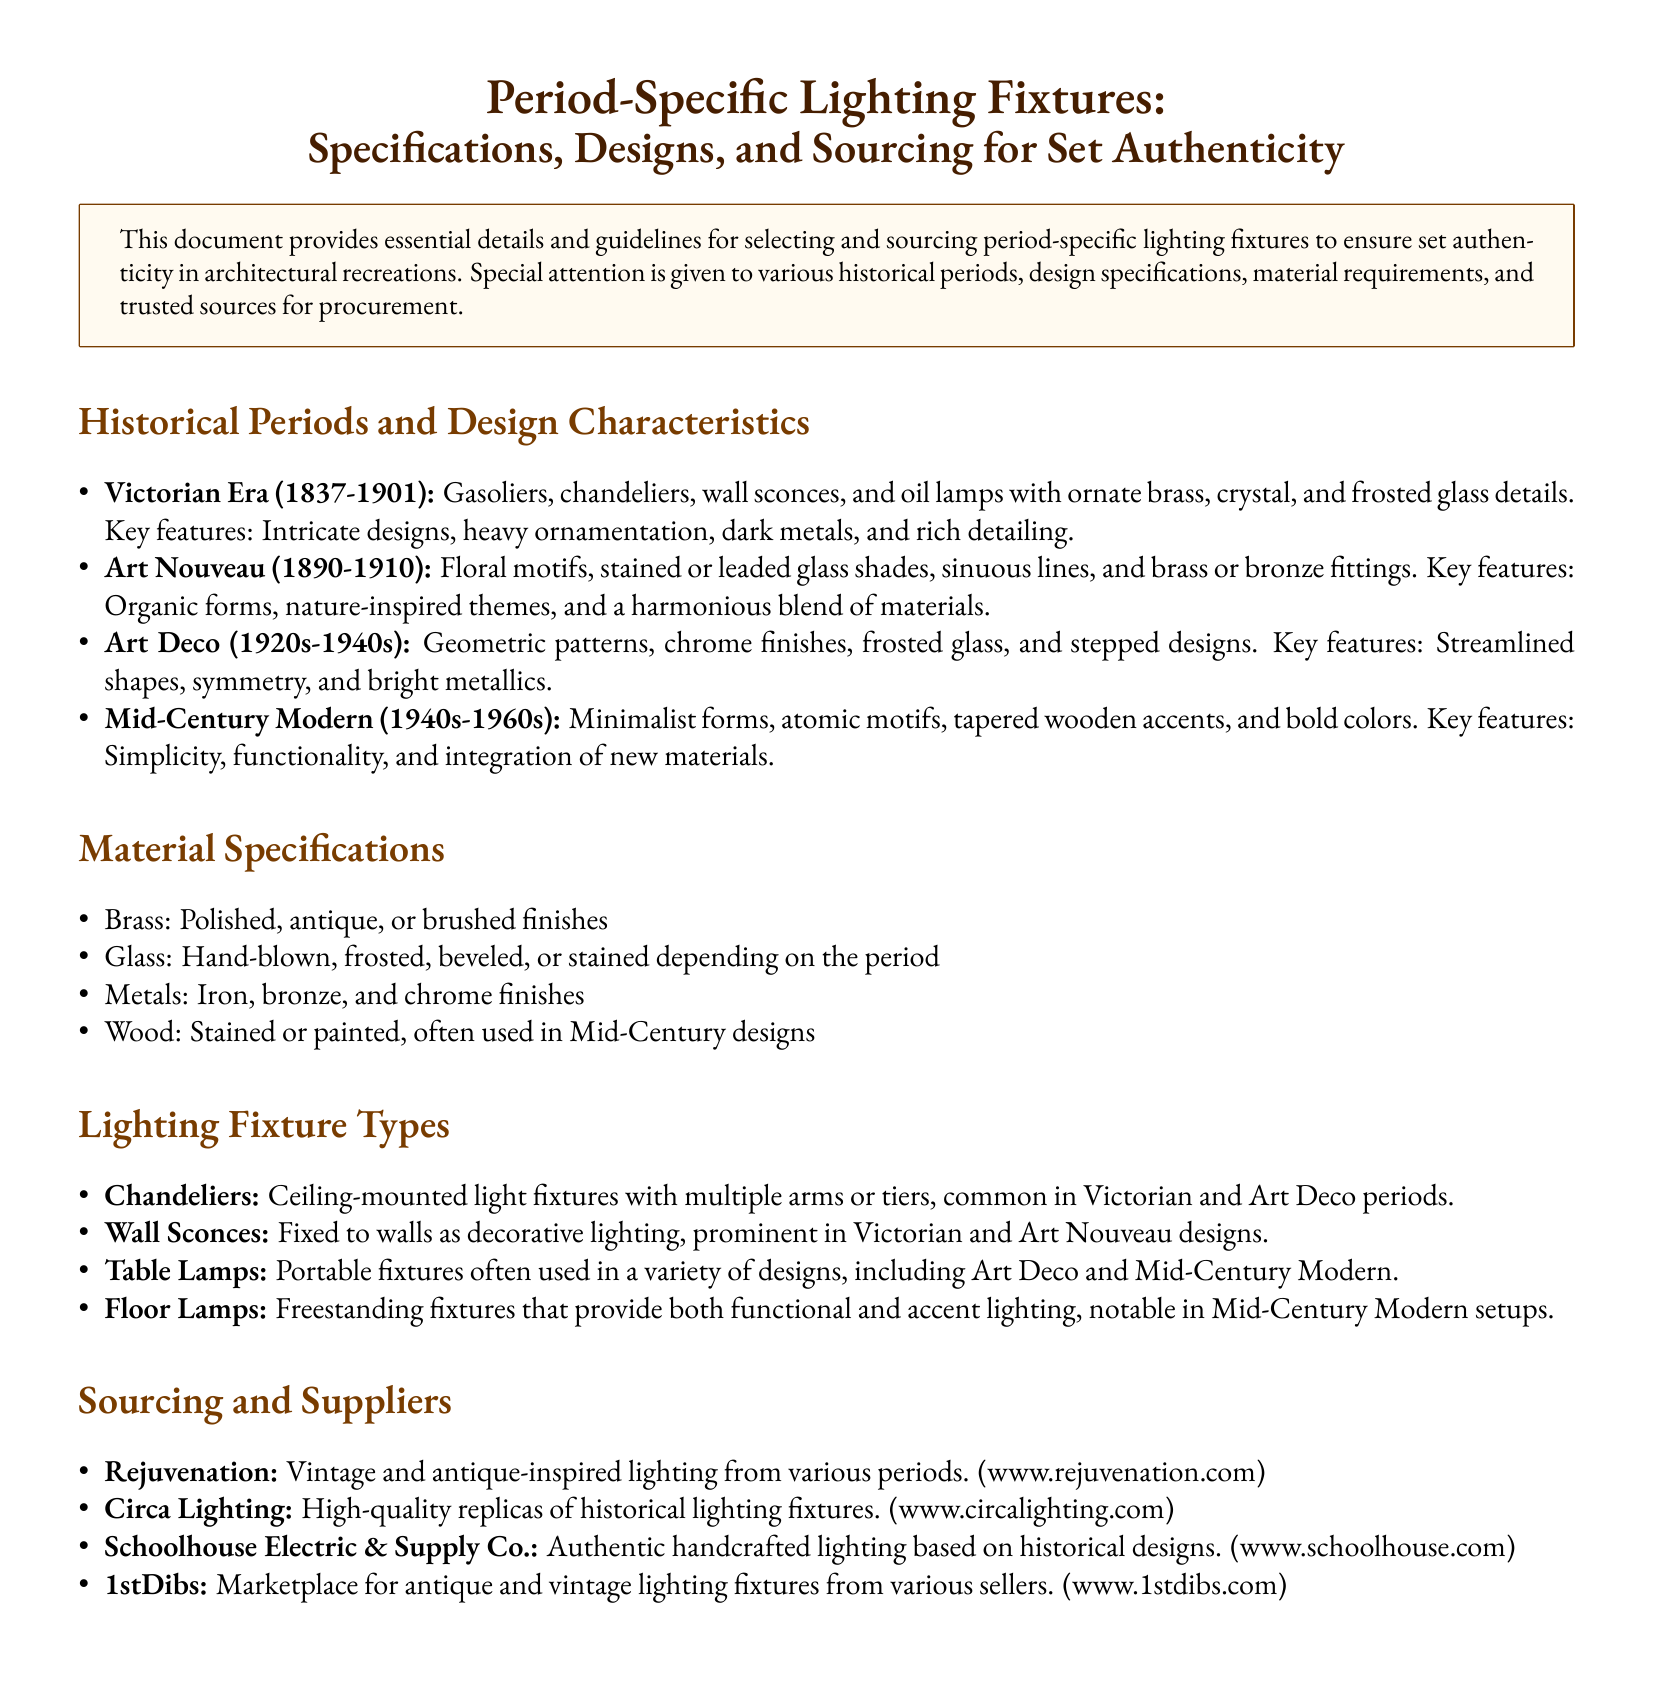What is the time period associated with the Victorian Era? The document states that the Victorian Era spans from 1837 to 1901.
Answer: 1837-1901 What type of motifs are prevalent in Art Nouveau designs? The document mentions that Art Nouveau features floral motifs.
Answer: Floral motifs Which material is specified for Mid-Century designs? The document lists wood as a material often used in Mid-Century designs.
Answer: Wood Which supplier is noted for vintage and antique-inspired lighting? The document indicates Rejuvenation as a supplier for vintage and antique-inspired lighting.
Answer: Rejuvenation What lighting fixture type is commonly ceiling-mounted and found in Victorian designs? The document refers to chandeliers as commonly ceiling-mounted in Victorian designs.
Answer: Chandeliers In which historical period are geometric patterns and chrome finishes prominent? The document identifies Art Deco as the period with geometric patterns and chrome finishes.
Answer: Art Deco How many types of lighting fixtures are listed in the document? The document details four types of lighting fixtures.
Answer: Four What is the style of glass commonly associated with the Victorian Era? The document states that frosted glass is a common style for Victorian lighting fixtures.
Answer: Frosted glass Which supplier offers a marketplace for antique and vintage lighting fixtures? The document mentions 1stDibs as the marketplace for antique and vintage lighting.
Answer: 1stDibs 